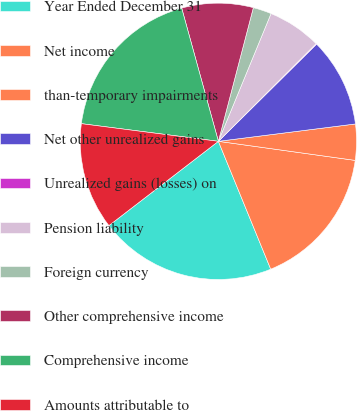Convert chart. <chart><loc_0><loc_0><loc_500><loc_500><pie_chart><fcel>Year Ended December 31<fcel>Net income<fcel>than-temporary impairments<fcel>Net other unrealized gains<fcel>Unrealized gains (losses) on<fcel>Pension liability<fcel>Foreign currency<fcel>Other comprehensive income<fcel>Comprehensive income<fcel>Amounts attributable to<nl><fcel>20.74%<fcel>16.61%<fcel>4.21%<fcel>10.41%<fcel>0.08%<fcel>6.28%<fcel>2.15%<fcel>8.35%<fcel>18.68%<fcel>12.48%<nl></chart> 